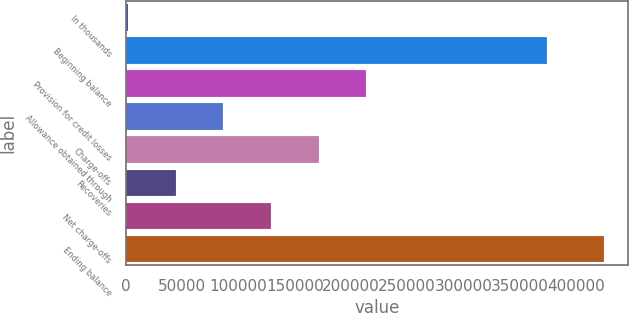Convert chart. <chart><loc_0><loc_0><loc_500><loc_500><bar_chart><fcel>In thousands<fcel>Beginning balance<fcel>Provision for credit losses<fcel>Allowance obtained through<fcel>Charge-offs<fcel>Recoveries<fcel>Net charge-offs<fcel>Ending balance<nl><fcel>2001<fcel>374703<fcel>213504<fcel>86602.4<fcel>171204<fcel>44301.7<fcel>128903<fcel>425008<nl></chart> 